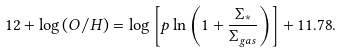Convert formula to latex. <formula><loc_0><loc_0><loc_500><loc_500>1 2 + \log { ( O / H ) } = \log { \left [ p \ln { \left ( 1 + \frac { \Sigma _ { * } } { \Sigma _ { g a s } } \right ) } \right ] + 1 1 . 7 8 } .</formula> 